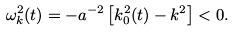<formula> <loc_0><loc_0><loc_500><loc_500>\omega ^ { 2 } _ { k } ( t ) = - a ^ { - 2 } \left [ k ^ { 2 } _ { 0 } ( t ) - k ^ { 2 } \right ] < 0 .</formula> 